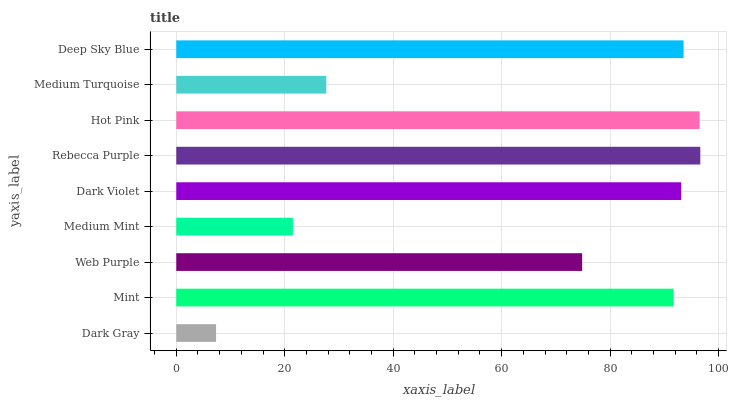Is Dark Gray the minimum?
Answer yes or no. Yes. Is Rebecca Purple the maximum?
Answer yes or no. Yes. Is Mint the minimum?
Answer yes or no. No. Is Mint the maximum?
Answer yes or no. No. Is Mint greater than Dark Gray?
Answer yes or no. Yes. Is Dark Gray less than Mint?
Answer yes or no. Yes. Is Dark Gray greater than Mint?
Answer yes or no. No. Is Mint less than Dark Gray?
Answer yes or no. No. Is Mint the high median?
Answer yes or no. Yes. Is Mint the low median?
Answer yes or no. Yes. Is Dark Violet the high median?
Answer yes or no. No. Is Medium Turquoise the low median?
Answer yes or no. No. 